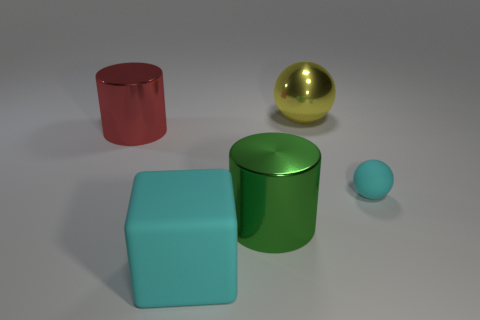Add 1 metallic objects. How many objects exist? 6 Subtract all cylinders. How many objects are left? 3 Subtract all small matte objects. Subtract all red metal things. How many objects are left? 3 Add 5 balls. How many balls are left? 7 Add 3 blocks. How many blocks exist? 4 Subtract 0 blue cylinders. How many objects are left? 5 